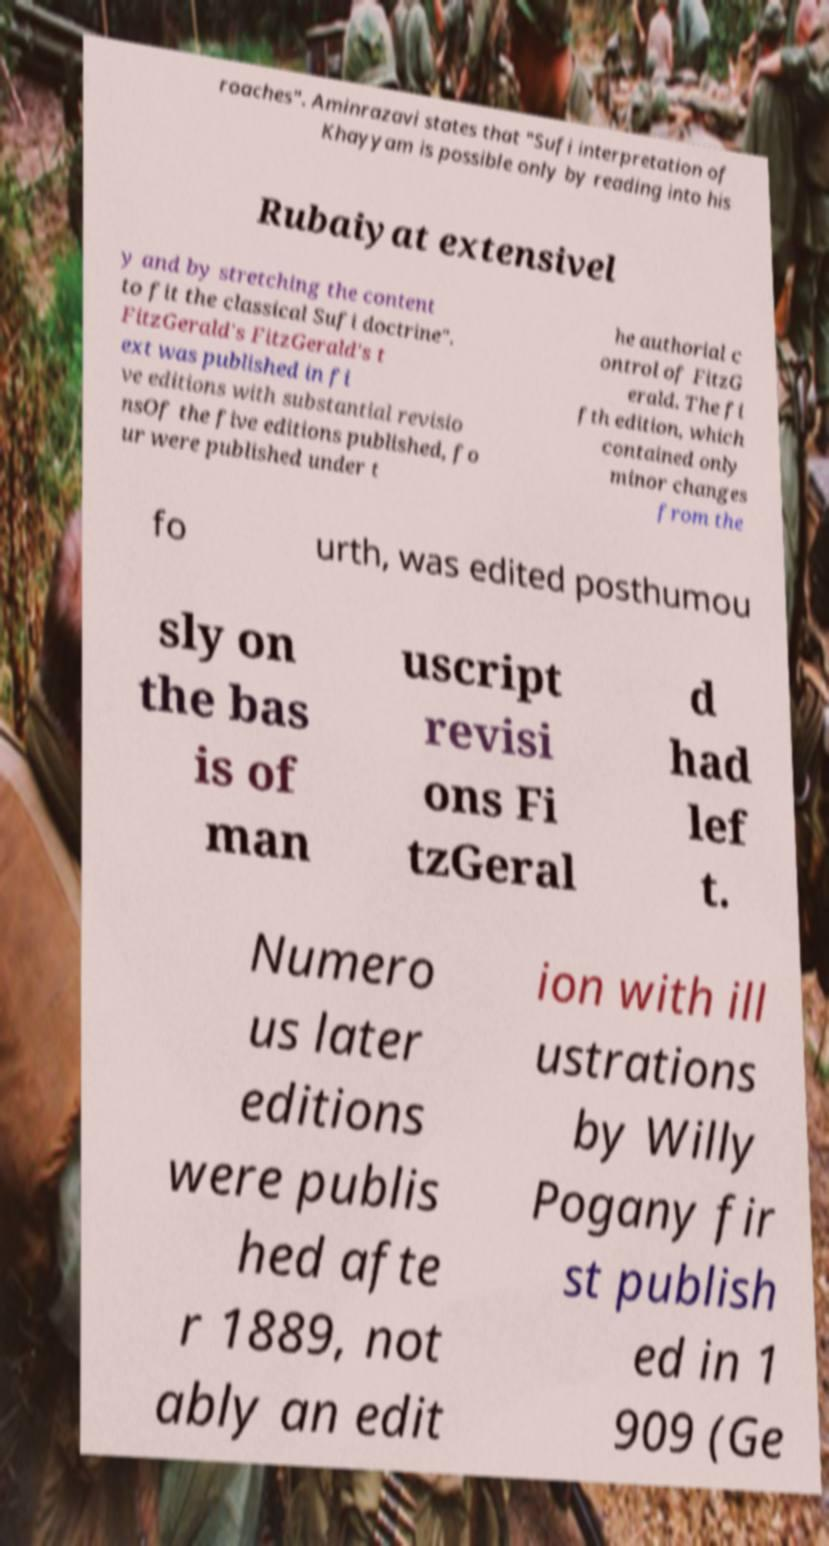Could you assist in decoding the text presented in this image and type it out clearly? roaches". Aminrazavi states that "Sufi interpretation of Khayyam is possible only by reading into his Rubaiyat extensivel y and by stretching the content to fit the classical Sufi doctrine". FitzGerald's FitzGerald's t ext was published in fi ve editions with substantial revisio nsOf the five editions published, fo ur were published under t he authorial c ontrol of FitzG erald. The fi fth edition, which contained only minor changes from the fo urth, was edited posthumou sly on the bas is of man uscript revisi ons Fi tzGeral d had lef t. Numero us later editions were publis hed afte r 1889, not ably an edit ion with ill ustrations by Willy Pogany fir st publish ed in 1 909 (Ge 